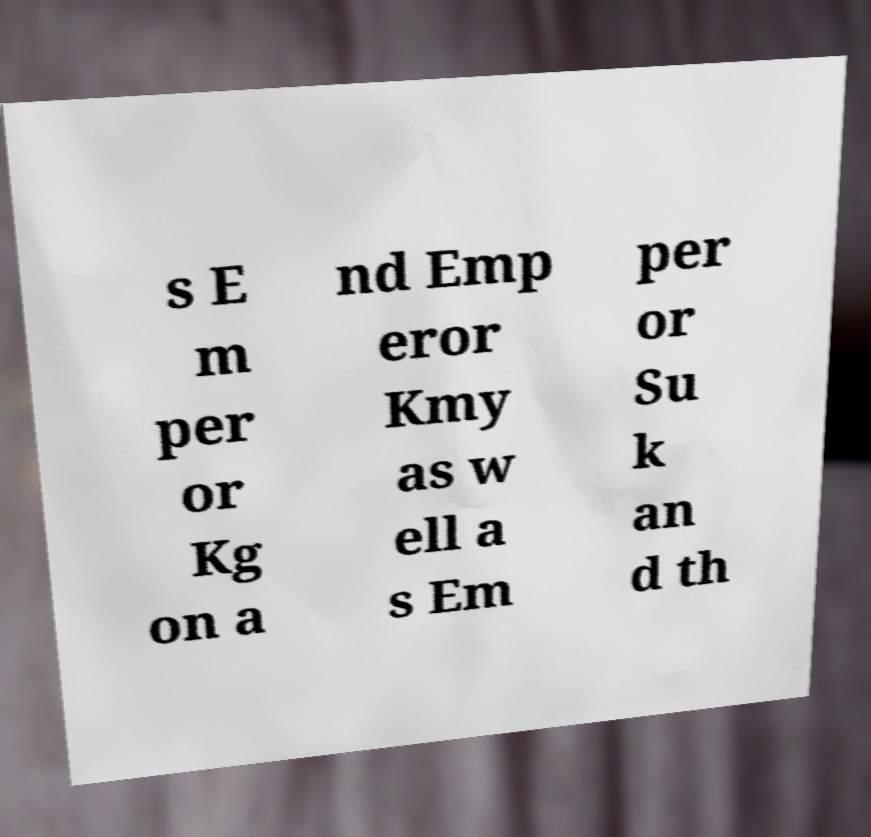Can you read and provide the text displayed in the image?This photo seems to have some interesting text. Can you extract and type it out for me? s E m per or Kg on a nd Emp eror Kmy as w ell a s Em per or Su k an d th 